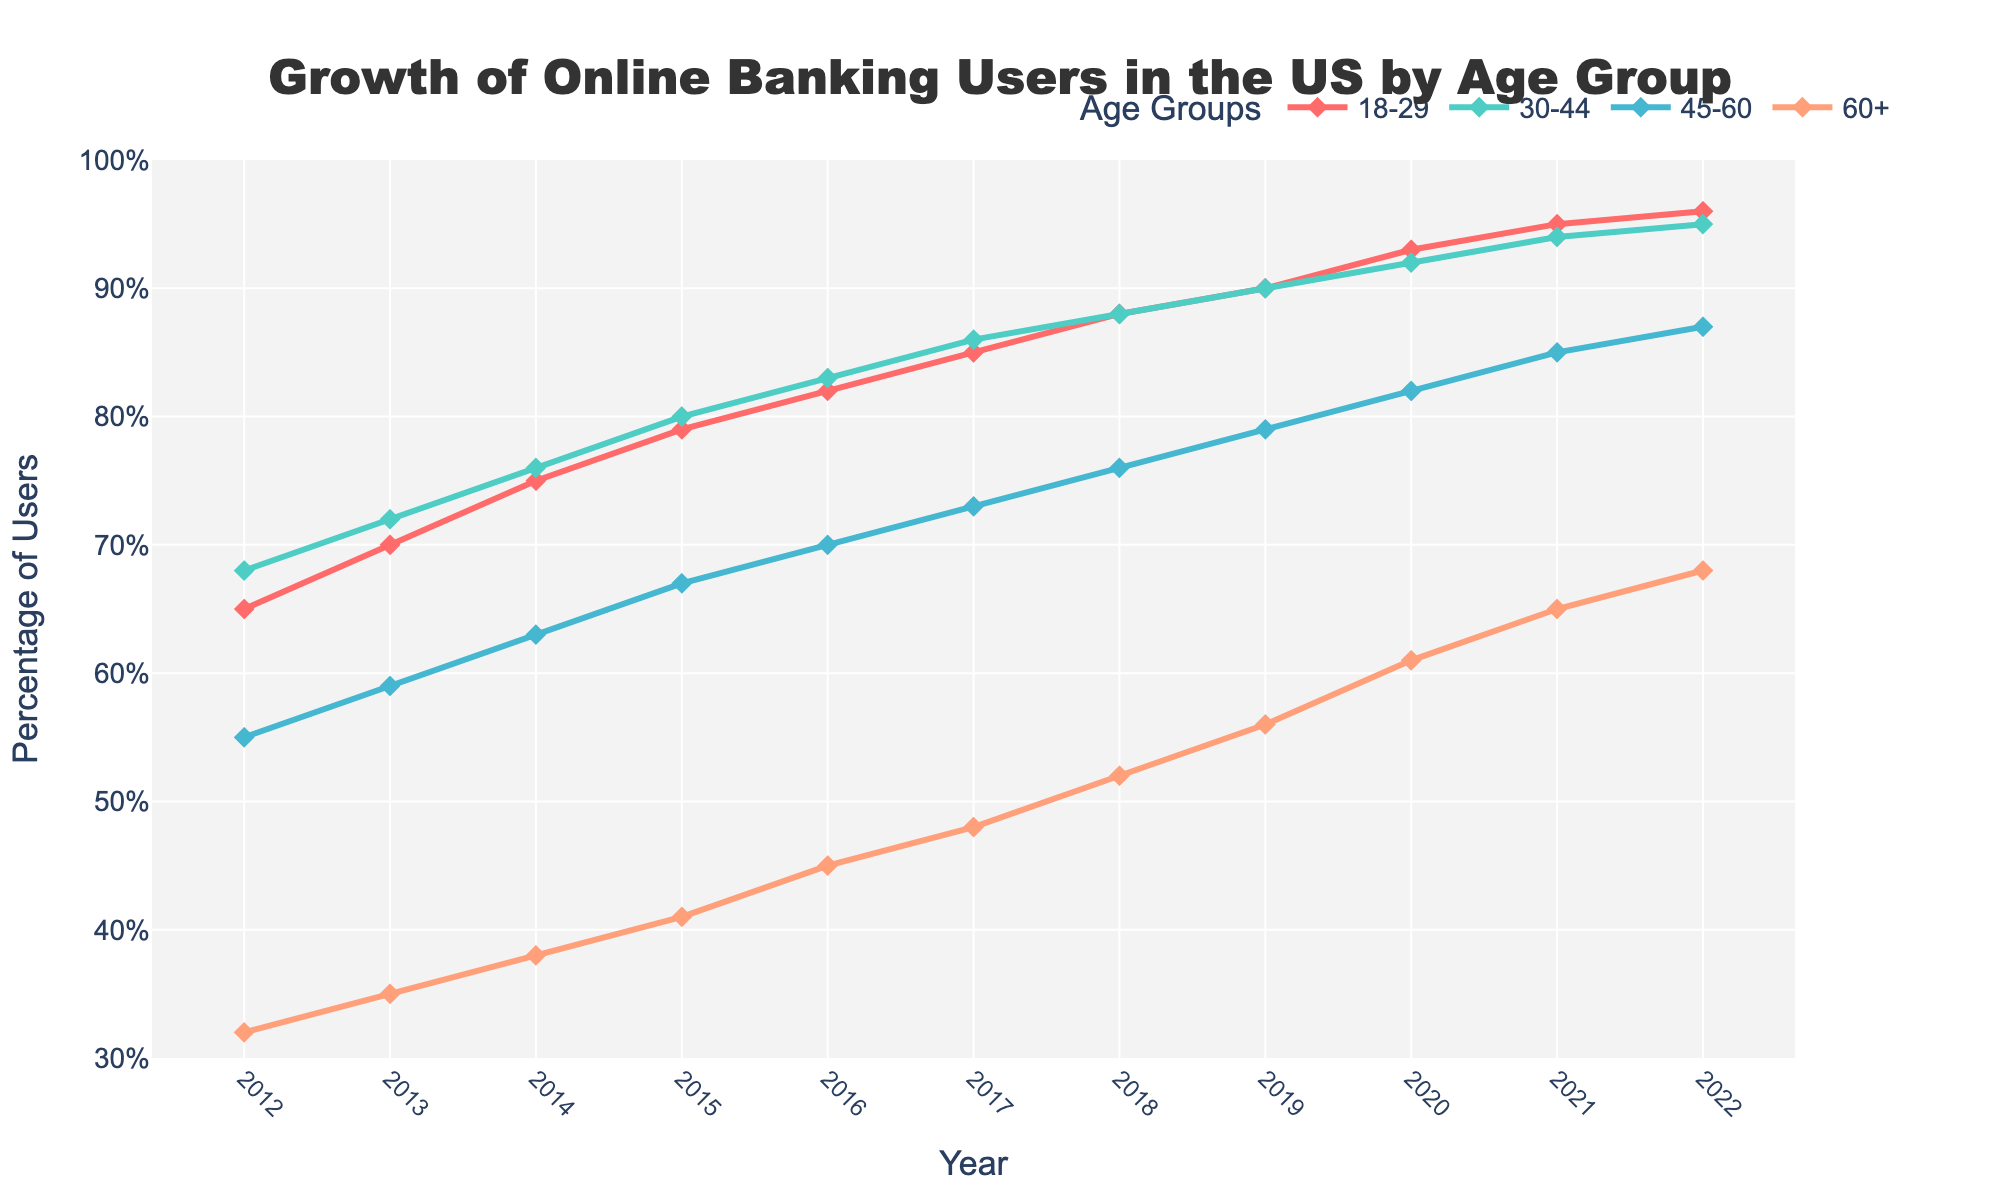What age group showed the highest percentage of online banking users in 2012? Look at the data points for 2012 across all age groups. Identify which group has the highest value.
Answer: 30-44 Which age group had the smallest growth in online banking users from 2012 to 2022? Compute the difference in percentage from 2012 to 2022 for each age group by subtracting the 2012 value from the 2022 value. Compare these differences to find the smallest one.
Answer: 18-29 By how much did the percentage of online banking users aged 60+ increase from 2012 to 2022? To find the increase, subtract the percentage of users in 2012 from the percentage of users in 2022 for the 60+ age group (68 - 32).
Answer: 36 What was the average percentage of online banking users for the age group 45-60 over the decade? Sum the percentages for the age group 45-60 from 2012 to 2022 and divide by the number of years (10). The calculation is (55 + 59 + 63 + 67 + 70 + 73 + 76 + 79 + 82 + 85 + 87) / 11.
Answer: 72.2 Which two age groups had the closest percentage of users in 2018, and what was their percentage? Look at the 2018 data points and find the two age groups with the smallest difference in their percentages. Compare the values for different pairs.
Answer: 30-44 and 18-29 (both 88%) Between 2012 and 2017, how much did the percentage of online banking users aged 18-29 increase? Subtract the 2012 value from the 2017 value for the age group 18-29 (85 - 65).
Answer: 20 In what year did the percentage of users aged 30-44 first reach 90%? Check the values for the 30-44 age group year by year and identify the year when it first reaches or exceeds 90%.
Answer: 2019 Which age group shows a consistent year-over-year increase in the percentage of users between 2012 and 2022? Examine the data points for each age group year by year to ensure there is an increase each year.
Answer: 60+ How many age groups had more than 80% online banking users by 2022? Look at the 2022 data points and count the number of groups with values greater than 80%.
Answer: 3 